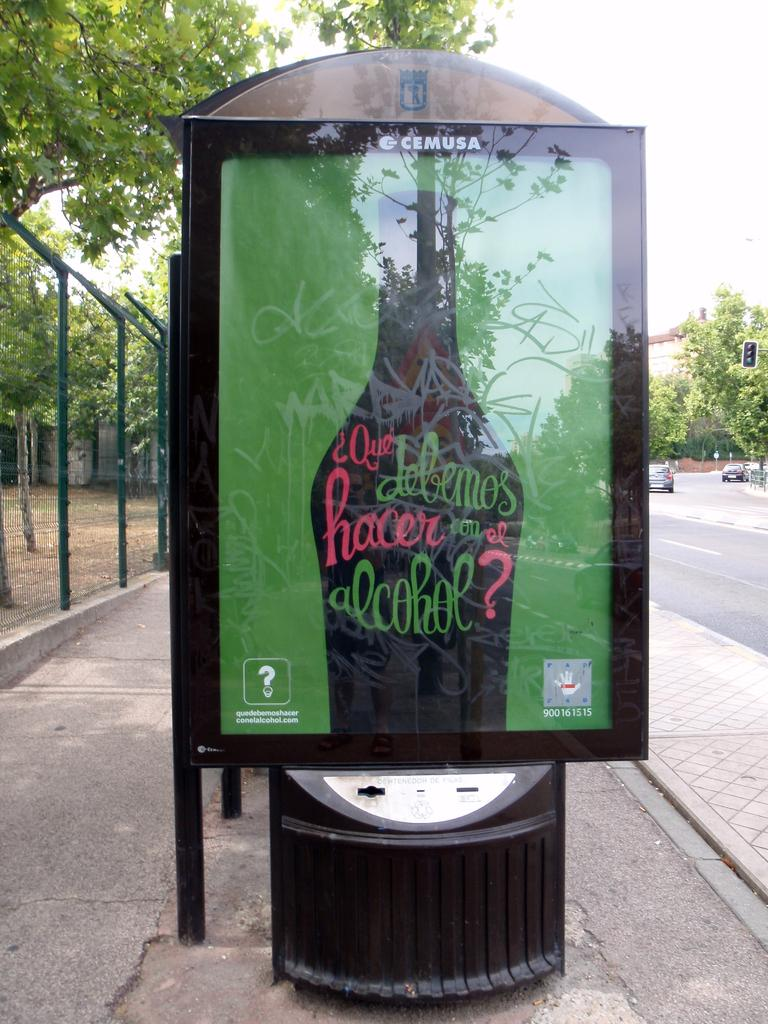<image>
Write a terse but informative summary of the picture. A bus stop shelter with an advertisement that says something about alcohol. 